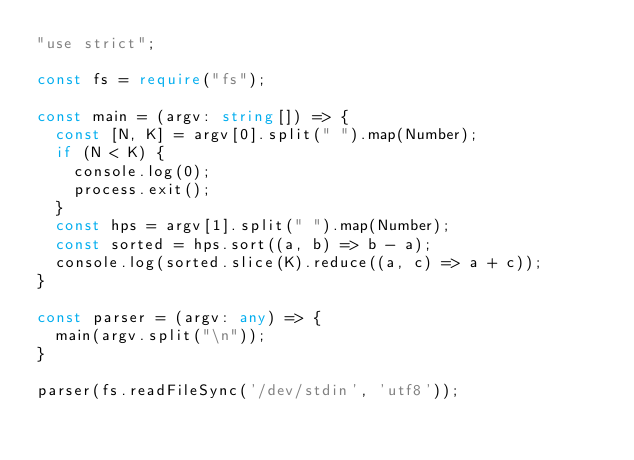<code> <loc_0><loc_0><loc_500><loc_500><_TypeScript_>"use strict";

const fs = require("fs");

const main = (argv: string[]) => {
  const [N, K] = argv[0].split(" ").map(Number);
  if (N < K) {
    console.log(0);
    process.exit();
  }
  const hps = argv[1].split(" ").map(Number);
  const sorted = hps.sort((a, b) => b - a);
  console.log(sorted.slice(K).reduce((a, c) => a + c));
}

const parser = (argv: any) => {
  main(argv.split("\n"));
}

parser(fs.readFileSync('/dev/stdin', 'utf8'));
</code> 